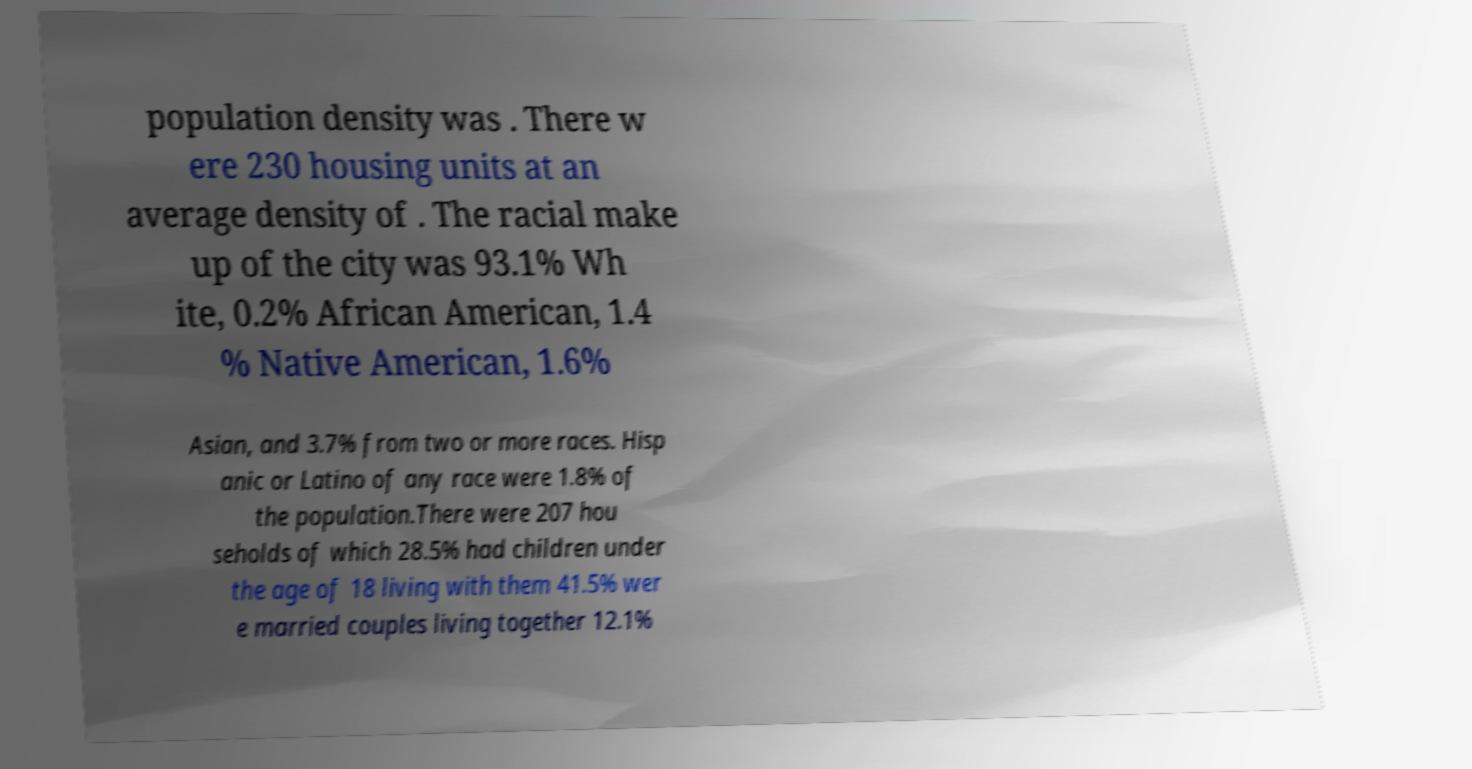Could you extract and type out the text from this image? population density was . There w ere 230 housing units at an average density of . The racial make up of the city was 93.1% Wh ite, 0.2% African American, 1.4 % Native American, 1.6% Asian, and 3.7% from two or more races. Hisp anic or Latino of any race were 1.8% of the population.There were 207 hou seholds of which 28.5% had children under the age of 18 living with them 41.5% wer e married couples living together 12.1% 